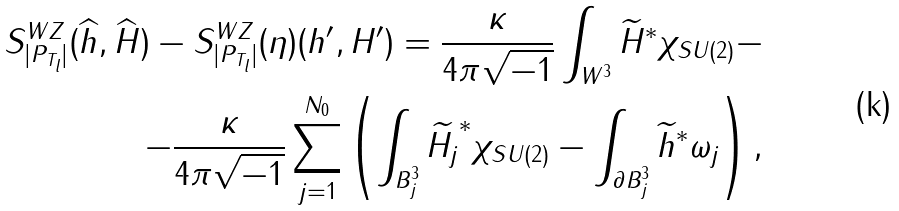Convert formula to latex. <formula><loc_0><loc_0><loc_500><loc_500>S _ { | P _ { T _ { l } } | } ^ { W Z } ( \widehat { h } , \widehat { H } ) - S _ { | P _ { T _ { l } } | } ^ { W Z } ( \eta ) ( h ^ { \prime } , H ^ { \prime } ) = \frac { \kappa } { 4 \pi \sqrt { - 1 } } \int _ { W ^ { 3 } } \widetilde { H } ^ { \ast } \chi _ { S U ( 2 ) } - \\ - \frac { \kappa } { 4 \pi \sqrt { - 1 } } \sum _ { j = 1 } ^ { N _ { 0 } } \left ( \int _ { B _ { j } ^ { 3 } } \widetilde { H _ { j } } ^ { \ast } \chi _ { S U ( 2 ) } - \int _ { \partial B _ { j } ^ { 3 } } \widetilde { h } ^ { \ast } \omega _ { j } \right ) ,</formula> 